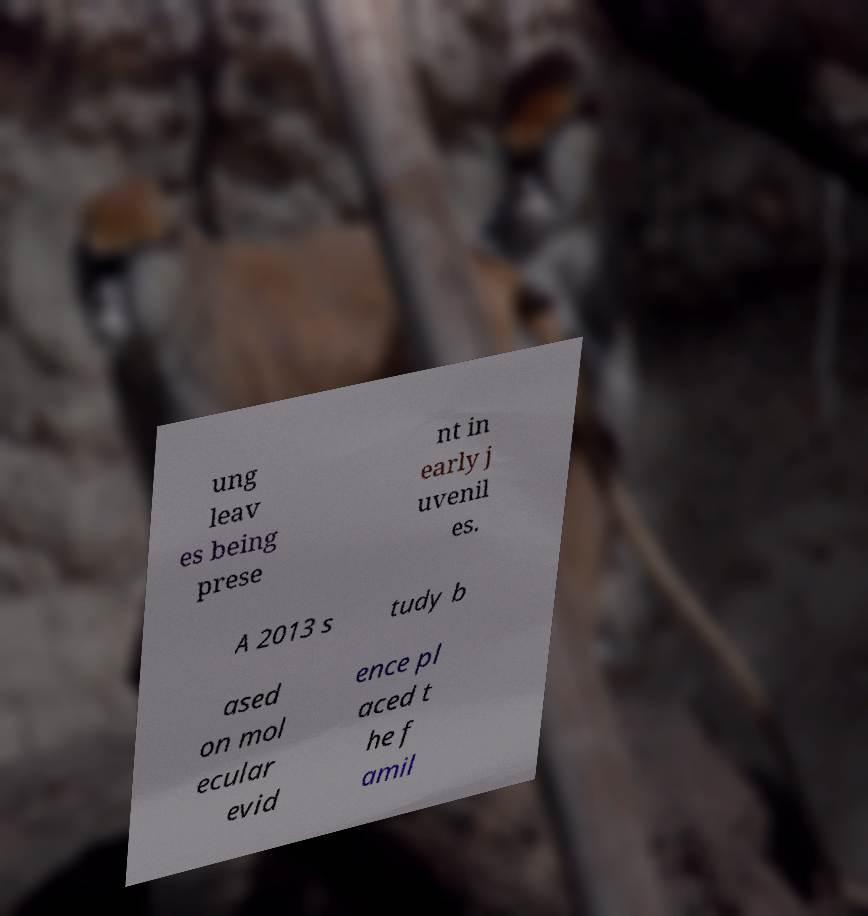Can you read and provide the text displayed in the image?This photo seems to have some interesting text. Can you extract and type it out for me? ung leav es being prese nt in early j uvenil es. A 2013 s tudy b ased on mol ecular evid ence pl aced t he f amil 